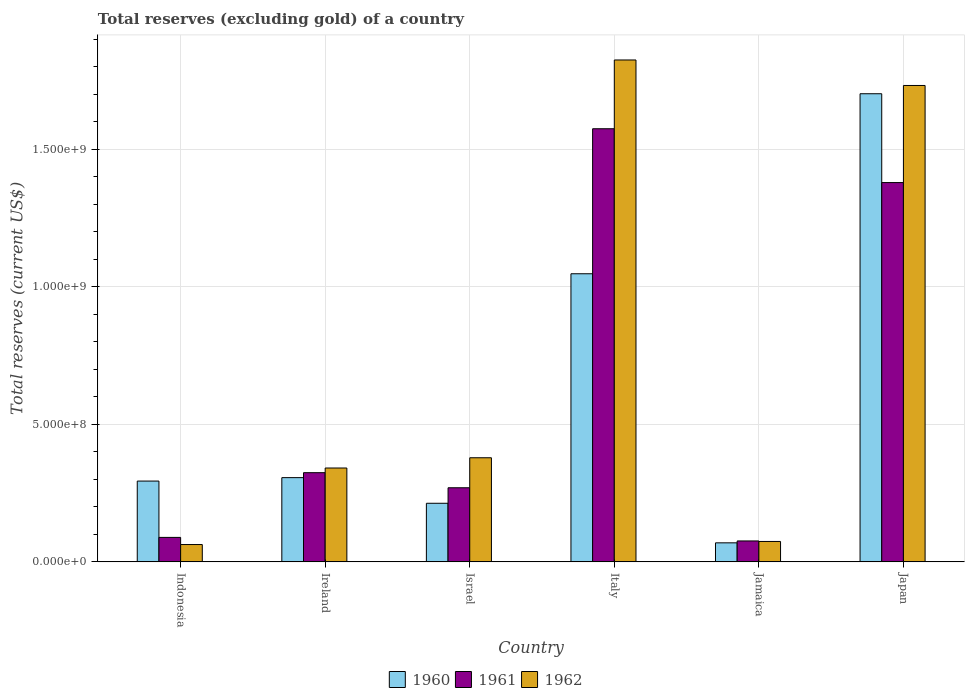How many groups of bars are there?
Offer a very short reply. 6. Are the number of bars per tick equal to the number of legend labels?
Offer a terse response. Yes. How many bars are there on the 6th tick from the left?
Provide a short and direct response. 3. How many bars are there on the 5th tick from the right?
Offer a very short reply. 3. What is the label of the 2nd group of bars from the left?
Your answer should be compact. Ireland. In how many cases, is the number of bars for a given country not equal to the number of legend labels?
Provide a short and direct response. 0. What is the total reserves (excluding gold) in 1961 in Jamaica?
Keep it short and to the point. 7.61e+07. Across all countries, what is the maximum total reserves (excluding gold) in 1960?
Keep it short and to the point. 1.70e+09. Across all countries, what is the minimum total reserves (excluding gold) in 1961?
Ensure brevity in your answer.  7.61e+07. In which country was the total reserves (excluding gold) in 1961 minimum?
Provide a short and direct response. Jamaica. What is the total total reserves (excluding gold) in 1961 in the graph?
Your answer should be compact. 3.71e+09. What is the difference between the total reserves (excluding gold) in 1960 in Israel and that in Jamaica?
Offer a very short reply. 1.44e+08. What is the difference between the total reserves (excluding gold) in 1960 in Indonesia and the total reserves (excluding gold) in 1962 in Italy?
Your response must be concise. -1.53e+09. What is the average total reserves (excluding gold) in 1960 per country?
Offer a terse response. 6.05e+08. What is the difference between the total reserves (excluding gold) of/in 1960 and total reserves (excluding gold) of/in 1962 in Indonesia?
Provide a succinct answer. 2.31e+08. In how many countries, is the total reserves (excluding gold) in 1960 greater than 1600000000 US$?
Your answer should be very brief. 1. What is the ratio of the total reserves (excluding gold) in 1960 in Italy to that in Japan?
Your answer should be compact. 0.62. What is the difference between the highest and the second highest total reserves (excluding gold) in 1961?
Make the answer very short. 1.05e+09. What is the difference between the highest and the lowest total reserves (excluding gold) in 1960?
Offer a very short reply. 1.63e+09. Is the sum of the total reserves (excluding gold) in 1962 in Israel and Italy greater than the maximum total reserves (excluding gold) in 1960 across all countries?
Your answer should be very brief. Yes. What does the 1st bar from the right in Ireland represents?
Provide a succinct answer. 1962. Is it the case that in every country, the sum of the total reserves (excluding gold) in 1961 and total reserves (excluding gold) in 1960 is greater than the total reserves (excluding gold) in 1962?
Give a very brief answer. Yes. How many bars are there?
Offer a very short reply. 18. Are all the bars in the graph horizontal?
Offer a terse response. No. Does the graph contain any zero values?
Give a very brief answer. No. Does the graph contain grids?
Your response must be concise. Yes. How many legend labels are there?
Your response must be concise. 3. How are the legend labels stacked?
Provide a succinct answer. Horizontal. What is the title of the graph?
Keep it short and to the point. Total reserves (excluding gold) of a country. What is the label or title of the X-axis?
Offer a terse response. Country. What is the label or title of the Y-axis?
Your response must be concise. Total reserves (current US$). What is the Total reserves (current US$) of 1960 in Indonesia?
Give a very brief answer. 2.94e+08. What is the Total reserves (current US$) of 1961 in Indonesia?
Keep it short and to the point. 8.90e+07. What is the Total reserves (current US$) in 1962 in Indonesia?
Offer a terse response. 6.30e+07. What is the Total reserves (current US$) in 1960 in Ireland?
Your response must be concise. 3.06e+08. What is the Total reserves (current US$) of 1961 in Ireland?
Provide a short and direct response. 3.24e+08. What is the Total reserves (current US$) in 1962 in Ireland?
Provide a short and direct response. 3.41e+08. What is the Total reserves (current US$) in 1960 in Israel?
Keep it short and to the point. 2.13e+08. What is the Total reserves (current US$) of 1961 in Israel?
Ensure brevity in your answer.  2.69e+08. What is the Total reserves (current US$) in 1962 in Israel?
Offer a terse response. 3.79e+08. What is the Total reserves (current US$) in 1960 in Italy?
Provide a short and direct response. 1.05e+09. What is the Total reserves (current US$) of 1961 in Italy?
Offer a very short reply. 1.57e+09. What is the Total reserves (current US$) of 1962 in Italy?
Ensure brevity in your answer.  1.82e+09. What is the Total reserves (current US$) in 1960 in Jamaica?
Ensure brevity in your answer.  6.92e+07. What is the Total reserves (current US$) in 1961 in Jamaica?
Your answer should be very brief. 7.61e+07. What is the Total reserves (current US$) in 1962 in Jamaica?
Your answer should be compact. 7.42e+07. What is the Total reserves (current US$) of 1960 in Japan?
Ensure brevity in your answer.  1.70e+09. What is the Total reserves (current US$) of 1961 in Japan?
Provide a short and direct response. 1.38e+09. What is the Total reserves (current US$) in 1962 in Japan?
Provide a succinct answer. 1.73e+09. Across all countries, what is the maximum Total reserves (current US$) of 1960?
Your answer should be compact. 1.70e+09. Across all countries, what is the maximum Total reserves (current US$) in 1961?
Offer a terse response. 1.57e+09. Across all countries, what is the maximum Total reserves (current US$) of 1962?
Give a very brief answer. 1.82e+09. Across all countries, what is the minimum Total reserves (current US$) in 1960?
Offer a very short reply. 6.92e+07. Across all countries, what is the minimum Total reserves (current US$) in 1961?
Your answer should be compact. 7.61e+07. Across all countries, what is the minimum Total reserves (current US$) in 1962?
Your answer should be very brief. 6.30e+07. What is the total Total reserves (current US$) in 1960 in the graph?
Provide a short and direct response. 3.63e+09. What is the total Total reserves (current US$) of 1961 in the graph?
Give a very brief answer. 3.71e+09. What is the total Total reserves (current US$) of 1962 in the graph?
Provide a succinct answer. 4.41e+09. What is the difference between the Total reserves (current US$) in 1960 in Indonesia and that in Ireland?
Give a very brief answer. -1.25e+07. What is the difference between the Total reserves (current US$) in 1961 in Indonesia and that in Ireland?
Make the answer very short. -2.35e+08. What is the difference between the Total reserves (current US$) in 1962 in Indonesia and that in Ireland?
Keep it short and to the point. -2.78e+08. What is the difference between the Total reserves (current US$) of 1960 in Indonesia and that in Israel?
Provide a short and direct response. 8.07e+07. What is the difference between the Total reserves (current US$) in 1961 in Indonesia and that in Israel?
Provide a succinct answer. -1.80e+08. What is the difference between the Total reserves (current US$) in 1962 in Indonesia and that in Israel?
Provide a short and direct response. -3.16e+08. What is the difference between the Total reserves (current US$) of 1960 in Indonesia and that in Italy?
Your answer should be very brief. -7.54e+08. What is the difference between the Total reserves (current US$) in 1961 in Indonesia and that in Italy?
Ensure brevity in your answer.  -1.49e+09. What is the difference between the Total reserves (current US$) in 1962 in Indonesia and that in Italy?
Offer a very short reply. -1.76e+09. What is the difference between the Total reserves (current US$) of 1960 in Indonesia and that in Jamaica?
Give a very brief answer. 2.25e+08. What is the difference between the Total reserves (current US$) in 1961 in Indonesia and that in Jamaica?
Provide a succinct answer. 1.29e+07. What is the difference between the Total reserves (current US$) in 1962 in Indonesia and that in Jamaica?
Provide a short and direct response. -1.12e+07. What is the difference between the Total reserves (current US$) in 1960 in Indonesia and that in Japan?
Your answer should be very brief. -1.41e+09. What is the difference between the Total reserves (current US$) in 1961 in Indonesia and that in Japan?
Offer a terse response. -1.29e+09. What is the difference between the Total reserves (current US$) in 1962 in Indonesia and that in Japan?
Your answer should be compact. -1.67e+09. What is the difference between the Total reserves (current US$) of 1960 in Ireland and that in Israel?
Your answer should be compact. 9.32e+07. What is the difference between the Total reserves (current US$) in 1961 in Ireland and that in Israel?
Provide a short and direct response. 5.48e+07. What is the difference between the Total reserves (current US$) of 1962 in Ireland and that in Israel?
Your response must be concise. -3.73e+07. What is the difference between the Total reserves (current US$) in 1960 in Ireland and that in Italy?
Offer a very short reply. -7.41e+08. What is the difference between the Total reserves (current US$) in 1961 in Ireland and that in Italy?
Your answer should be very brief. -1.25e+09. What is the difference between the Total reserves (current US$) of 1962 in Ireland and that in Italy?
Your response must be concise. -1.48e+09. What is the difference between the Total reserves (current US$) of 1960 in Ireland and that in Jamaica?
Your answer should be compact. 2.37e+08. What is the difference between the Total reserves (current US$) in 1961 in Ireland and that in Jamaica?
Provide a succinct answer. 2.48e+08. What is the difference between the Total reserves (current US$) in 1962 in Ireland and that in Jamaica?
Offer a terse response. 2.67e+08. What is the difference between the Total reserves (current US$) in 1960 in Ireland and that in Japan?
Make the answer very short. -1.40e+09. What is the difference between the Total reserves (current US$) of 1961 in Ireland and that in Japan?
Make the answer very short. -1.05e+09. What is the difference between the Total reserves (current US$) of 1962 in Ireland and that in Japan?
Make the answer very short. -1.39e+09. What is the difference between the Total reserves (current US$) of 1960 in Israel and that in Italy?
Keep it short and to the point. -8.34e+08. What is the difference between the Total reserves (current US$) of 1961 in Israel and that in Italy?
Your answer should be compact. -1.31e+09. What is the difference between the Total reserves (current US$) of 1962 in Israel and that in Italy?
Your answer should be compact. -1.45e+09. What is the difference between the Total reserves (current US$) in 1960 in Israel and that in Jamaica?
Offer a terse response. 1.44e+08. What is the difference between the Total reserves (current US$) in 1961 in Israel and that in Jamaica?
Your answer should be very brief. 1.93e+08. What is the difference between the Total reserves (current US$) in 1962 in Israel and that in Jamaica?
Offer a very short reply. 3.04e+08. What is the difference between the Total reserves (current US$) in 1960 in Israel and that in Japan?
Your response must be concise. -1.49e+09. What is the difference between the Total reserves (current US$) in 1961 in Israel and that in Japan?
Offer a very short reply. -1.11e+09. What is the difference between the Total reserves (current US$) of 1962 in Israel and that in Japan?
Give a very brief answer. -1.35e+09. What is the difference between the Total reserves (current US$) of 1960 in Italy and that in Jamaica?
Your answer should be compact. 9.78e+08. What is the difference between the Total reserves (current US$) of 1961 in Italy and that in Jamaica?
Give a very brief answer. 1.50e+09. What is the difference between the Total reserves (current US$) of 1962 in Italy and that in Jamaica?
Your response must be concise. 1.75e+09. What is the difference between the Total reserves (current US$) of 1960 in Italy and that in Japan?
Provide a succinct answer. -6.55e+08. What is the difference between the Total reserves (current US$) of 1961 in Italy and that in Japan?
Your answer should be compact. 1.96e+08. What is the difference between the Total reserves (current US$) of 1962 in Italy and that in Japan?
Your response must be concise. 9.27e+07. What is the difference between the Total reserves (current US$) of 1960 in Jamaica and that in Japan?
Make the answer very short. -1.63e+09. What is the difference between the Total reserves (current US$) of 1961 in Jamaica and that in Japan?
Provide a short and direct response. -1.30e+09. What is the difference between the Total reserves (current US$) of 1962 in Jamaica and that in Japan?
Give a very brief answer. -1.66e+09. What is the difference between the Total reserves (current US$) of 1960 in Indonesia and the Total reserves (current US$) of 1961 in Ireland?
Provide a short and direct response. -3.05e+07. What is the difference between the Total reserves (current US$) in 1960 in Indonesia and the Total reserves (current US$) in 1962 in Ireland?
Offer a very short reply. -4.75e+07. What is the difference between the Total reserves (current US$) of 1961 in Indonesia and the Total reserves (current US$) of 1962 in Ireland?
Your response must be concise. -2.52e+08. What is the difference between the Total reserves (current US$) of 1960 in Indonesia and the Total reserves (current US$) of 1961 in Israel?
Give a very brief answer. 2.43e+07. What is the difference between the Total reserves (current US$) of 1960 in Indonesia and the Total reserves (current US$) of 1962 in Israel?
Keep it short and to the point. -8.48e+07. What is the difference between the Total reserves (current US$) in 1961 in Indonesia and the Total reserves (current US$) in 1962 in Israel?
Your answer should be very brief. -2.90e+08. What is the difference between the Total reserves (current US$) in 1960 in Indonesia and the Total reserves (current US$) in 1961 in Italy?
Your response must be concise. -1.28e+09. What is the difference between the Total reserves (current US$) of 1960 in Indonesia and the Total reserves (current US$) of 1962 in Italy?
Provide a succinct answer. -1.53e+09. What is the difference between the Total reserves (current US$) of 1961 in Indonesia and the Total reserves (current US$) of 1962 in Italy?
Ensure brevity in your answer.  -1.74e+09. What is the difference between the Total reserves (current US$) of 1960 in Indonesia and the Total reserves (current US$) of 1961 in Jamaica?
Your answer should be very brief. 2.18e+08. What is the difference between the Total reserves (current US$) of 1960 in Indonesia and the Total reserves (current US$) of 1962 in Jamaica?
Give a very brief answer. 2.20e+08. What is the difference between the Total reserves (current US$) of 1961 in Indonesia and the Total reserves (current US$) of 1962 in Jamaica?
Provide a succinct answer. 1.48e+07. What is the difference between the Total reserves (current US$) in 1960 in Indonesia and the Total reserves (current US$) in 1961 in Japan?
Offer a terse response. -1.09e+09. What is the difference between the Total reserves (current US$) of 1960 in Indonesia and the Total reserves (current US$) of 1962 in Japan?
Provide a succinct answer. -1.44e+09. What is the difference between the Total reserves (current US$) in 1961 in Indonesia and the Total reserves (current US$) in 1962 in Japan?
Provide a short and direct response. -1.64e+09. What is the difference between the Total reserves (current US$) of 1960 in Ireland and the Total reserves (current US$) of 1961 in Israel?
Offer a very short reply. 3.68e+07. What is the difference between the Total reserves (current US$) of 1960 in Ireland and the Total reserves (current US$) of 1962 in Israel?
Offer a terse response. -7.23e+07. What is the difference between the Total reserves (current US$) in 1961 in Ireland and the Total reserves (current US$) in 1962 in Israel?
Offer a very short reply. -5.43e+07. What is the difference between the Total reserves (current US$) of 1960 in Ireland and the Total reserves (current US$) of 1961 in Italy?
Provide a succinct answer. -1.27e+09. What is the difference between the Total reserves (current US$) of 1960 in Ireland and the Total reserves (current US$) of 1962 in Italy?
Offer a terse response. -1.52e+09. What is the difference between the Total reserves (current US$) of 1961 in Ireland and the Total reserves (current US$) of 1962 in Italy?
Offer a terse response. -1.50e+09. What is the difference between the Total reserves (current US$) of 1960 in Ireland and the Total reserves (current US$) of 1961 in Jamaica?
Provide a succinct answer. 2.30e+08. What is the difference between the Total reserves (current US$) of 1960 in Ireland and the Total reserves (current US$) of 1962 in Jamaica?
Your answer should be very brief. 2.32e+08. What is the difference between the Total reserves (current US$) of 1961 in Ireland and the Total reserves (current US$) of 1962 in Jamaica?
Provide a short and direct response. 2.50e+08. What is the difference between the Total reserves (current US$) of 1960 in Ireland and the Total reserves (current US$) of 1961 in Japan?
Provide a short and direct response. -1.07e+09. What is the difference between the Total reserves (current US$) in 1960 in Ireland and the Total reserves (current US$) in 1962 in Japan?
Your answer should be compact. -1.43e+09. What is the difference between the Total reserves (current US$) of 1961 in Ireland and the Total reserves (current US$) of 1962 in Japan?
Give a very brief answer. -1.41e+09. What is the difference between the Total reserves (current US$) in 1960 in Israel and the Total reserves (current US$) in 1961 in Italy?
Offer a terse response. -1.36e+09. What is the difference between the Total reserves (current US$) of 1960 in Israel and the Total reserves (current US$) of 1962 in Italy?
Keep it short and to the point. -1.61e+09. What is the difference between the Total reserves (current US$) in 1961 in Israel and the Total reserves (current US$) in 1962 in Italy?
Your answer should be compact. -1.56e+09. What is the difference between the Total reserves (current US$) in 1960 in Israel and the Total reserves (current US$) in 1961 in Jamaica?
Make the answer very short. 1.37e+08. What is the difference between the Total reserves (current US$) in 1960 in Israel and the Total reserves (current US$) in 1962 in Jamaica?
Ensure brevity in your answer.  1.39e+08. What is the difference between the Total reserves (current US$) in 1961 in Israel and the Total reserves (current US$) in 1962 in Jamaica?
Keep it short and to the point. 1.95e+08. What is the difference between the Total reserves (current US$) of 1960 in Israel and the Total reserves (current US$) of 1961 in Japan?
Ensure brevity in your answer.  -1.17e+09. What is the difference between the Total reserves (current US$) of 1960 in Israel and the Total reserves (current US$) of 1962 in Japan?
Give a very brief answer. -1.52e+09. What is the difference between the Total reserves (current US$) in 1961 in Israel and the Total reserves (current US$) in 1962 in Japan?
Your response must be concise. -1.46e+09. What is the difference between the Total reserves (current US$) of 1960 in Italy and the Total reserves (current US$) of 1961 in Jamaica?
Ensure brevity in your answer.  9.71e+08. What is the difference between the Total reserves (current US$) in 1960 in Italy and the Total reserves (current US$) in 1962 in Jamaica?
Provide a short and direct response. 9.73e+08. What is the difference between the Total reserves (current US$) in 1961 in Italy and the Total reserves (current US$) in 1962 in Jamaica?
Give a very brief answer. 1.50e+09. What is the difference between the Total reserves (current US$) in 1960 in Italy and the Total reserves (current US$) in 1961 in Japan?
Give a very brief answer. -3.32e+08. What is the difference between the Total reserves (current US$) in 1960 in Italy and the Total reserves (current US$) in 1962 in Japan?
Your answer should be compact. -6.85e+08. What is the difference between the Total reserves (current US$) of 1961 in Italy and the Total reserves (current US$) of 1962 in Japan?
Make the answer very short. -1.57e+08. What is the difference between the Total reserves (current US$) in 1960 in Jamaica and the Total reserves (current US$) in 1961 in Japan?
Offer a terse response. -1.31e+09. What is the difference between the Total reserves (current US$) in 1960 in Jamaica and the Total reserves (current US$) in 1962 in Japan?
Make the answer very short. -1.66e+09. What is the difference between the Total reserves (current US$) of 1961 in Jamaica and the Total reserves (current US$) of 1962 in Japan?
Ensure brevity in your answer.  -1.66e+09. What is the average Total reserves (current US$) in 1960 per country?
Offer a very short reply. 6.05e+08. What is the average Total reserves (current US$) in 1961 per country?
Your answer should be very brief. 6.19e+08. What is the average Total reserves (current US$) in 1962 per country?
Your answer should be compact. 7.36e+08. What is the difference between the Total reserves (current US$) in 1960 and Total reserves (current US$) in 1961 in Indonesia?
Give a very brief answer. 2.05e+08. What is the difference between the Total reserves (current US$) of 1960 and Total reserves (current US$) of 1962 in Indonesia?
Your answer should be compact. 2.31e+08. What is the difference between the Total reserves (current US$) of 1961 and Total reserves (current US$) of 1962 in Indonesia?
Give a very brief answer. 2.60e+07. What is the difference between the Total reserves (current US$) in 1960 and Total reserves (current US$) in 1961 in Ireland?
Offer a very short reply. -1.80e+07. What is the difference between the Total reserves (current US$) in 1960 and Total reserves (current US$) in 1962 in Ireland?
Your response must be concise. -3.50e+07. What is the difference between the Total reserves (current US$) of 1961 and Total reserves (current US$) of 1962 in Ireland?
Make the answer very short. -1.70e+07. What is the difference between the Total reserves (current US$) in 1960 and Total reserves (current US$) in 1961 in Israel?
Your answer should be very brief. -5.64e+07. What is the difference between the Total reserves (current US$) of 1960 and Total reserves (current US$) of 1962 in Israel?
Make the answer very short. -1.66e+08. What is the difference between the Total reserves (current US$) of 1961 and Total reserves (current US$) of 1962 in Israel?
Offer a very short reply. -1.09e+08. What is the difference between the Total reserves (current US$) in 1960 and Total reserves (current US$) in 1961 in Italy?
Give a very brief answer. -5.27e+08. What is the difference between the Total reserves (current US$) of 1960 and Total reserves (current US$) of 1962 in Italy?
Provide a succinct answer. -7.77e+08. What is the difference between the Total reserves (current US$) in 1961 and Total reserves (current US$) in 1962 in Italy?
Offer a terse response. -2.50e+08. What is the difference between the Total reserves (current US$) in 1960 and Total reserves (current US$) in 1961 in Jamaica?
Your answer should be very brief. -6.90e+06. What is the difference between the Total reserves (current US$) of 1960 and Total reserves (current US$) of 1962 in Jamaica?
Offer a very short reply. -5.00e+06. What is the difference between the Total reserves (current US$) in 1961 and Total reserves (current US$) in 1962 in Jamaica?
Offer a terse response. 1.90e+06. What is the difference between the Total reserves (current US$) in 1960 and Total reserves (current US$) in 1961 in Japan?
Offer a terse response. 3.23e+08. What is the difference between the Total reserves (current US$) in 1960 and Total reserves (current US$) in 1962 in Japan?
Your response must be concise. -3.00e+07. What is the difference between the Total reserves (current US$) in 1961 and Total reserves (current US$) in 1962 in Japan?
Your answer should be very brief. -3.53e+08. What is the ratio of the Total reserves (current US$) in 1960 in Indonesia to that in Ireland?
Your answer should be very brief. 0.96. What is the ratio of the Total reserves (current US$) in 1961 in Indonesia to that in Ireland?
Make the answer very short. 0.27. What is the ratio of the Total reserves (current US$) of 1962 in Indonesia to that in Ireland?
Make the answer very short. 0.18. What is the ratio of the Total reserves (current US$) of 1960 in Indonesia to that in Israel?
Give a very brief answer. 1.38. What is the ratio of the Total reserves (current US$) of 1961 in Indonesia to that in Israel?
Your answer should be compact. 0.33. What is the ratio of the Total reserves (current US$) in 1962 in Indonesia to that in Israel?
Give a very brief answer. 0.17. What is the ratio of the Total reserves (current US$) of 1960 in Indonesia to that in Italy?
Your answer should be compact. 0.28. What is the ratio of the Total reserves (current US$) of 1961 in Indonesia to that in Italy?
Offer a very short reply. 0.06. What is the ratio of the Total reserves (current US$) of 1962 in Indonesia to that in Italy?
Provide a succinct answer. 0.03. What is the ratio of the Total reserves (current US$) in 1960 in Indonesia to that in Jamaica?
Provide a short and direct response. 4.24. What is the ratio of the Total reserves (current US$) of 1961 in Indonesia to that in Jamaica?
Provide a succinct answer. 1.17. What is the ratio of the Total reserves (current US$) of 1962 in Indonesia to that in Jamaica?
Provide a succinct answer. 0.85. What is the ratio of the Total reserves (current US$) of 1960 in Indonesia to that in Japan?
Your answer should be compact. 0.17. What is the ratio of the Total reserves (current US$) of 1961 in Indonesia to that in Japan?
Make the answer very short. 0.06. What is the ratio of the Total reserves (current US$) in 1962 in Indonesia to that in Japan?
Keep it short and to the point. 0.04. What is the ratio of the Total reserves (current US$) in 1960 in Ireland to that in Israel?
Ensure brevity in your answer.  1.44. What is the ratio of the Total reserves (current US$) in 1961 in Ireland to that in Israel?
Give a very brief answer. 1.2. What is the ratio of the Total reserves (current US$) of 1962 in Ireland to that in Israel?
Provide a short and direct response. 0.9. What is the ratio of the Total reserves (current US$) of 1960 in Ireland to that in Italy?
Your answer should be compact. 0.29. What is the ratio of the Total reserves (current US$) in 1961 in Ireland to that in Italy?
Provide a short and direct response. 0.21. What is the ratio of the Total reserves (current US$) in 1962 in Ireland to that in Italy?
Offer a very short reply. 0.19. What is the ratio of the Total reserves (current US$) in 1960 in Ireland to that in Jamaica?
Your response must be concise. 4.43. What is the ratio of the Total reserves (current US$) of 1961 in Ireland to that in Jamaica?
Make the answer very short. 4.26. What is the ratio of the Total reserves (current US$) of 1962 in Ireland to that in Jamaica?
Your answer should be compact. 4.6. What is the ratio of the Total reserves (current US$) of 1960 in Ireland to that in Japan?
Keep it short and to the point. 0.18. What is the ratio of the Total reserves (current US$) of 1961 in Ireland to that in Japan?
Your answer should be very brief. 0.24. What is the ratio of the Total reserves (current US$) of 1962 in Ireland to that in Japan?
Provide a short and direct response. 0.2. What is the ratio of the Total reserves (current US$) of 1960 in Israel to that in Italy?
Provide a short and direct response. 0.2. What is the ratio of the Total reserves (current US$) of 1961 in Israel to that in Italy?
Ensure brevity in your answer.  0.17. What is the ratio of the Total reserves (current US$) in 1962 in Israel to that in Italy?
Your answer should be very brief. 0.21. What is the ratio of the Total reserves (current US$) of 1960 in Israel to that in Jamaica?
Ensure brevity in your answer.  3.08. What is the ratio of the Total reserves (current US$) of 1961 in Israel to that in Jamaica?
Offer a very short reply. 3.54. What is the ratio of the Total reserves (current US$) of 1962 in Israel to that in Jamaica?
Ensure brevity in your answer.  5.1. What is the ratio of the Total reserves (current US$) in 1960 in Israel to that in Japan?
Offer a very short reply. 0.13. What is the ratio of the Total reserves (current US$) of 1961 in Israel to that in Japan?
Your response must be concise. 0.2. What is the ratio of the Total reserves (current US$) in 1962 in Israel to that in Japan?
Ensure brevity in your answer.  0.22. What is the ratio of the Total reserves (current US$) in 1960 in Italy to that in Jamaica?
Provide a succinct answer. 15.14. What is the ratio of the Total reserves (current US$) of 1961 in Italy to that in Jamaica?
Your answer should be compact. 20.69. What is the ratio of the Total reserves (current US$) in 1962 in Italy to that in Jamaica?
Offer a very short reply. 24.59. What is the ratio of the Total reserves (current US$) in 1960 in Italy to that in Japan?
Make the answer very short. 0.62. What is the ratio of the Total reserves (current US$) in 1961 in Italy to that in Japan?
Your response must be concise. 1.14. What is the ratio of the Total reserves (current US$) in 1962 in Italy to that in Japan?
Make the answer very short. 1.05. What is the ratio of the Total reserves (current US$) in 1960 in Jamaica to that in Japan?
Keep it short and to the point. 0.04. What is the ratio of the Total reserves (current US$) in 1961 in Jamaica to that in Japan?
Provide a succinct answer. 0.06. What is the ratio of the Total reserves (current US$) of 1962 in Jamaica to that in Japan?
Ensure brevity in your answer.  0.04. What is the difference between the highest and the second highest Total reserves (current US$) in 1960?
Give a very brief answer. 6.55e+08. What is the difference between the highest and the second highest Total reserves (current US$) in 1961?
Your response must be concise. 1.96e+08. What is the difference between the highest and the second highest Total reserves (current US$) in 1962?
Your answer should be very brief. 9.27e+07. What is the difference between the highest and the lowest Total reserves (current US$) in 1960?
Your response must be concise. 1.63e+09. What is the difference between the highest and the lowest Total reserves (current US$) in 1961?
Offer a terse response. 1.50e+09. What is the difference between the highest and the lowest Total reserves (current US$) in 1962?
Give a very brief answer. 1.76e+09. 